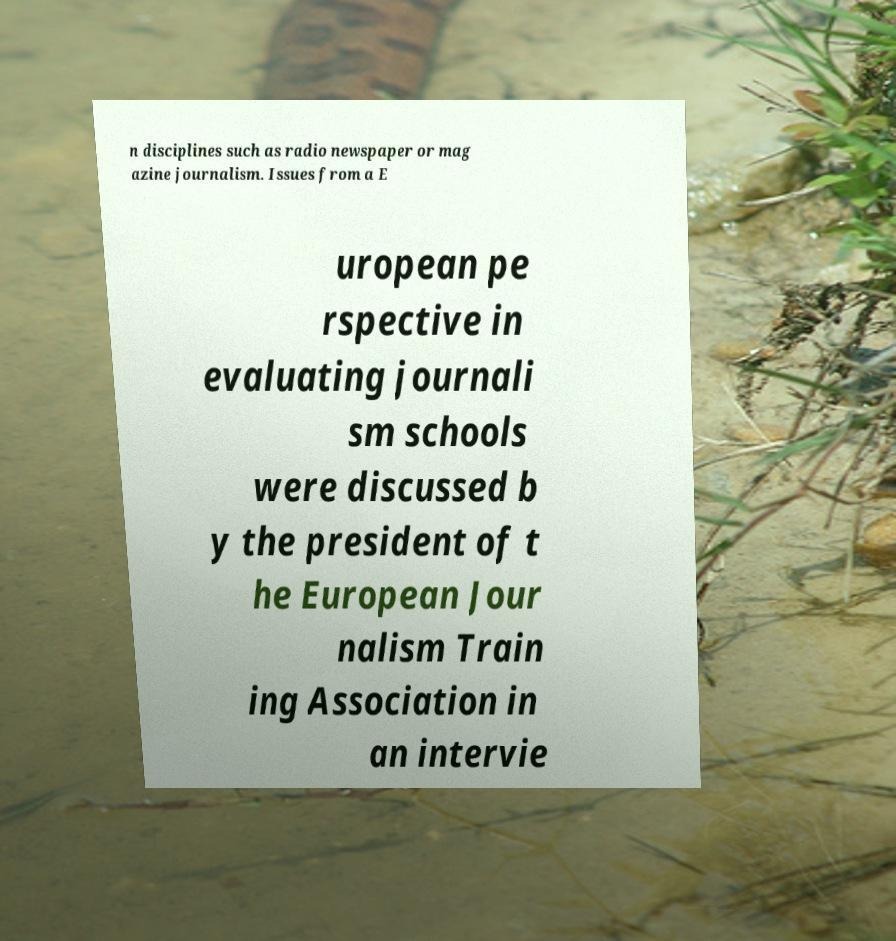There's text embedded in this image that I need extracted. Can you transcribe it verbatim? n disciplines such as radio newspaper or mag azine journalism. Issues from a E uropean pe rspective in evaluating journali sm schools were discussed b y the president of t he European Jour nalism Train ing Association in an intervie 